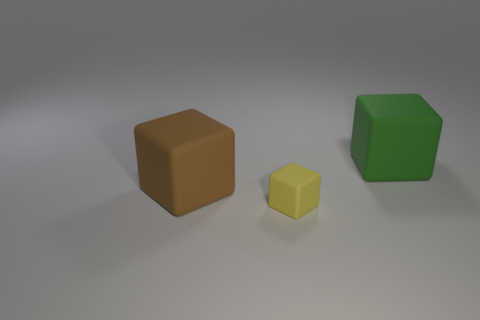Subtract all green blocks. How many blocks are left? 2 Subtract all green cubes. How many cubes are left? 2 Add 1 brown rubber objects. How many objects exist? 4 Subtract 1 cubes. How many cubes are left? 2 Subtract 1 yellow blocks. How many objects are left? 2 Subtract all gray blocks. Subtract all gray spheres. How many blocks are left? 3 Subtract all brown cylinders. How many red blocks are left? 0 Subtract all big brown metal spheres. Subtract all matte cubes. How many objects are left? 0 Add 1 brown cubes. How many brown cubes are left? 2 Add 1 green rubber objects. How many green rubber objects exist? 2 